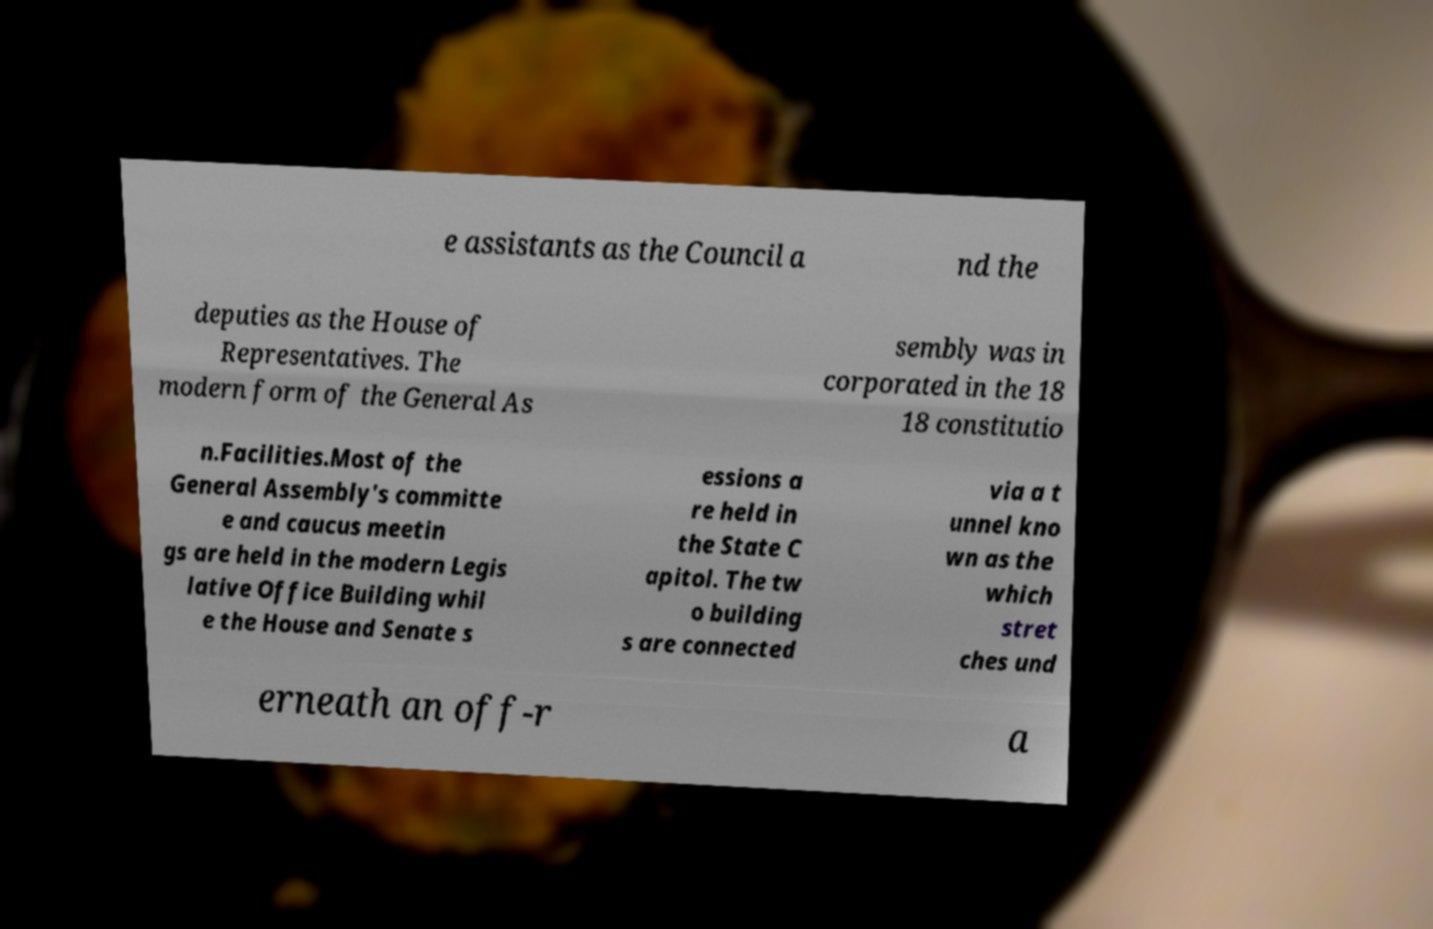For documentation purposes, I need the text within this image transcribed. Could you provide that? e assistants as the Council a nd the deputies as the House of Representatives. The modern form of the General As sembly was in corporated in the 18 18 constitutio n.Facilities.Most of the General Assembly's committe e and caucus meetin gs are held in the modern Legis lative Office Building whil e the House and Senate s essions a re held in the State C apitol. The tw o building s are connected via a t unnel kno wn as the which stret ches und erneath an off-r a 